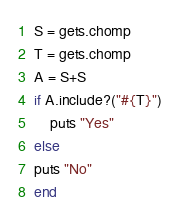<code> <loc_0><loc_0><loc_500><loc_500><_Ruby_>S = gets.chomp
T = gets.chomp
A = S+S
if A.include?("#{T}")
    puts "Yes"
else
puts "No"
end
</code> 